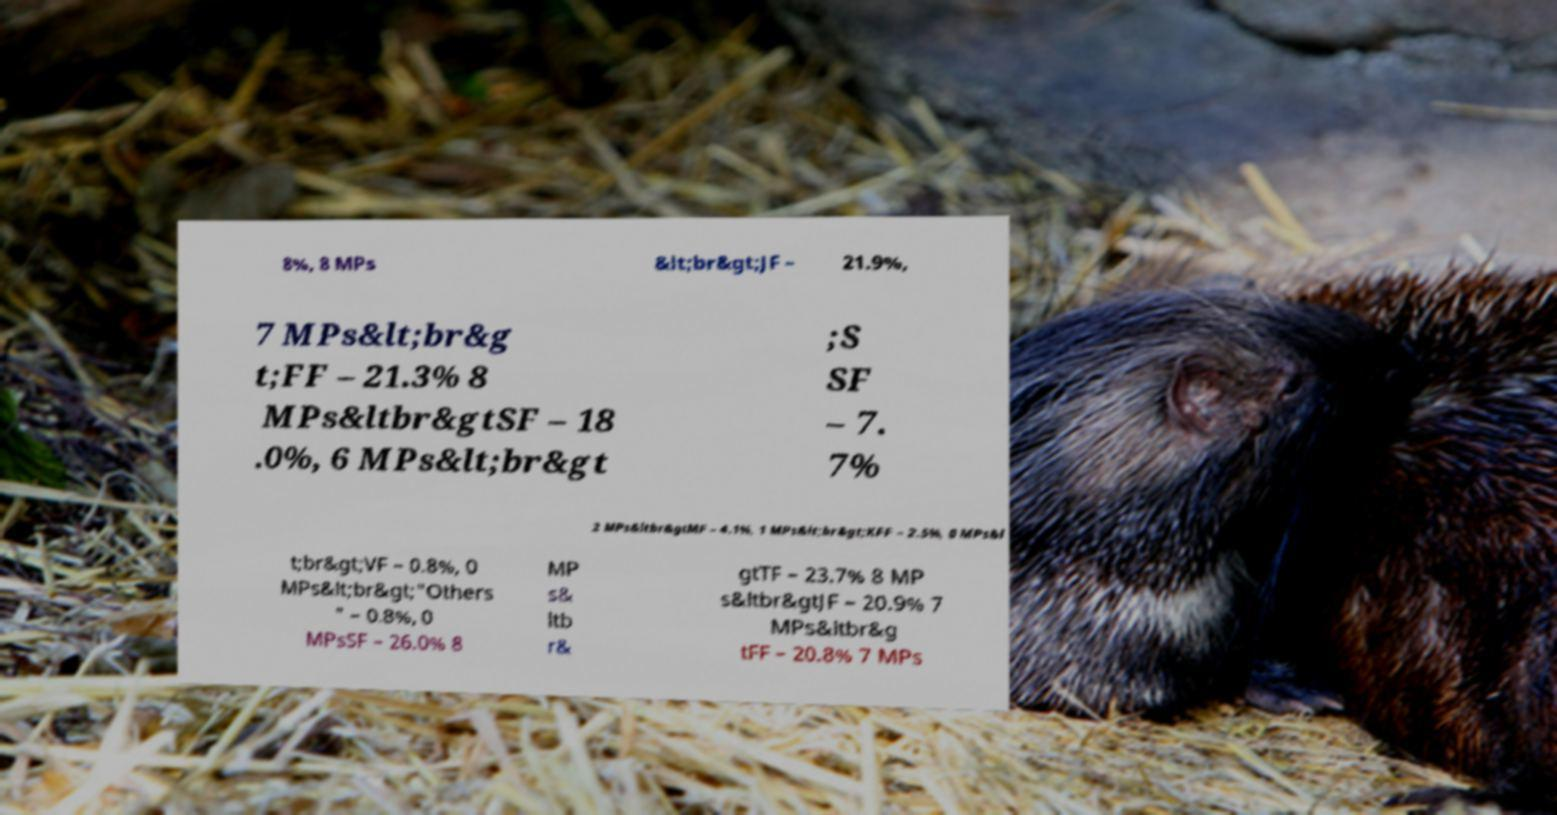Could you extract and type out the text from this image? 8%, 8 MPs &lt;br&gt;JF – 21.9%, 7 MPs&lt;br&g t;FF – 21.3% 8 MPs&ltbr&gtSF – 18 .0%, 6 MPs&lt;br&gt ;S SF – 7. 7% 2 MPs&ltbr&gtMF – 4.1%, 1 MPs&lt;br&gt;KFF – 2.5%, 0 MPs&l t;br&gt;VF – 0.8%, 0 MPs&lt;br&gt;"Others " – 0.8%, 0 MPsSF – 26.0% 8 MP s& ltb r& gtTF – 23.7% 8 MP s&ltbr&gtJF – 20.9% 7 MPs&ltbr&g tFF – 20.8% 7 MPs 